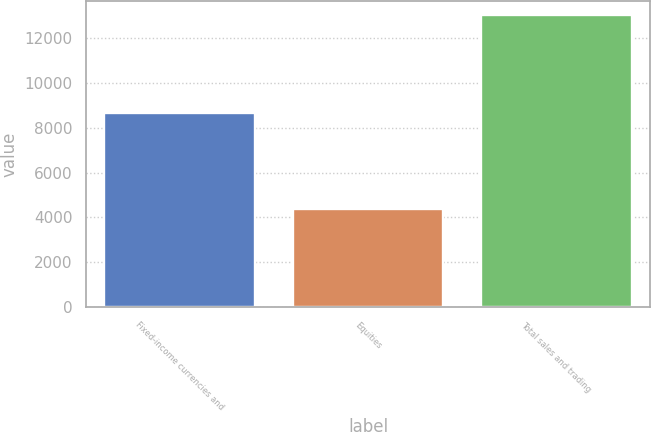<chart> <loc_0><loc_0><loc_500><loc_500><bar_chart><fcel>Fixed-income currencies and<fcel>Equities<fcel>Total sales and trading<nl><fcel>8632<fcel>4358<fcel>12990<nl></chart> 